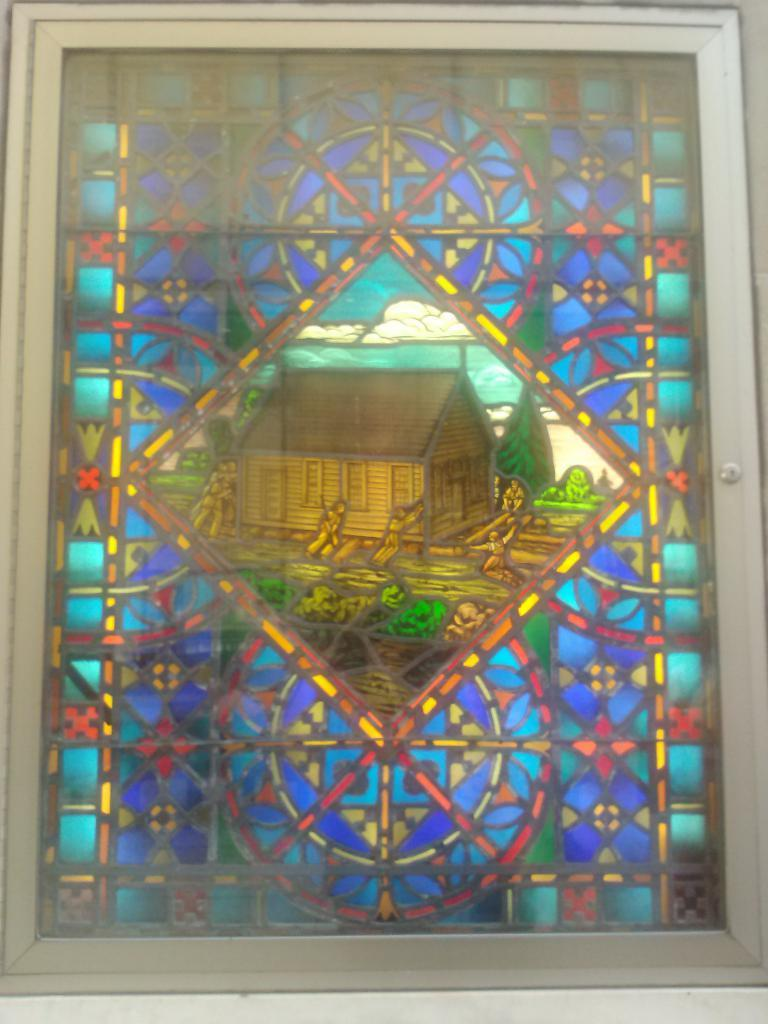What type of art is featured in the image? There is a modern art piece in the image. Can you describe the surface on which the art piece is placed? The modern art piece is on a glass surface. How many cherries are floating in the ocean in the image? There are no cherries or ocean present in the image; it features a modern art piece on a glass surface. 